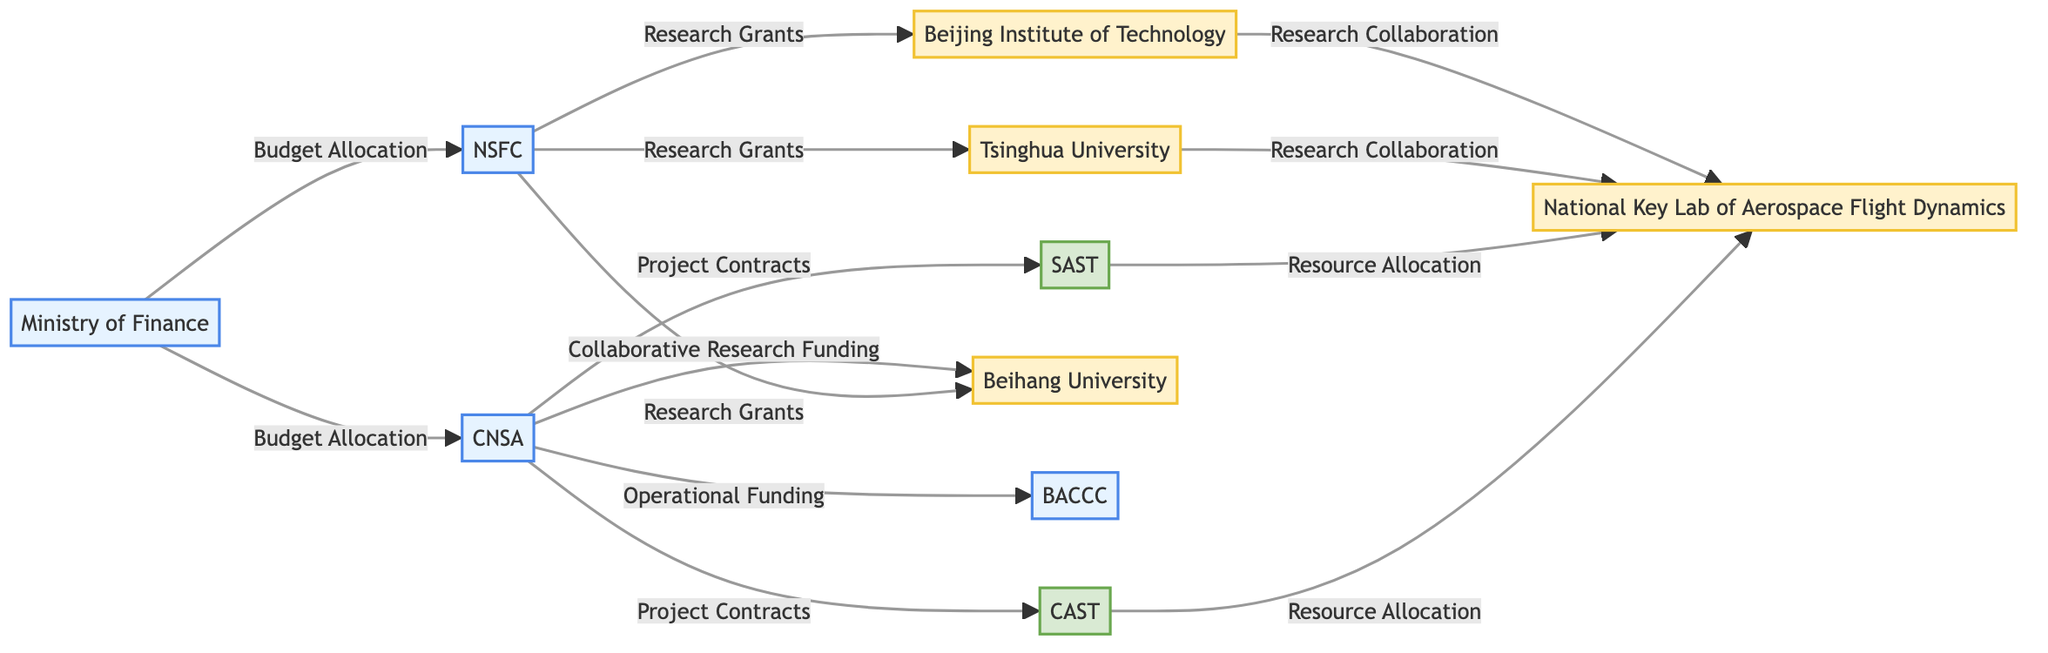What is the total number of nodes in the diagram? The diagram includes nodes representing various entities involved in space debris management. By counting the individual nodes listed, we find that there are 10 distinct nodes.
Answer: 10 Which government agency has connections to Beijing Aerospace Command and Control Center? According to the edges in the diagram, the China National Space Administration has a direct connection to the Beijing Aerospace Command and Control Center through Operational Funding.
Answer: CNSA How many research institutions received research grants from NSFC? The diagram indicates three research institutions that have incoming edges from the National Natural Science Foundation for research grants: Tsinghua University, Beijing Institute of Technology, and Beihang University. Counting these gives us a total of three institutions.
Answer: 3 What type of funding connects CNSA to CAST? The diagram specifies that the connection between CNSA and CAST is through Project Contracts. This funding type is shown explicitly in the edges of the diagram linking these two nodes.
Answer: Project Contracts Which node has the most outgoing connections? Evaluating the outgoing edges from each node, we see that the China National Space Administration has four outgoing connections: to BACCC, CAST, SAST, and Beihang University. No other node exceeds this count, indicating that CNSA has the most connections.
Answer: CNSA Which research institution collaborates with both NSFC and CAST? The edge from NSFC to Tsinghua University and the edge from CAST to National Key Laboratory of Aerospace Flight Dynamics collectively suggest that Tsinghua University has collaborations with NSFC and another link to CAST through resource allocation. Thus, Tsinghua University is the institution that links to both.
Answer: Tsinghua University What is the main source of budget allocation for CNSA? According to the diagram, the main source of budget allocation for the China National Space Administration is indicated to come from the Ministry of Finance, as shown by the connecting edge between the two nodes.
Answer: Ministry of Finance Identify the relationship type between Beijing Institute of Technology and the National Key Laboratory of Aerospace Flight Dynamics. In the diagram, the (Beijing Institute of Technology connects to National Key Laboratory of Aerospace Flight Dynamics through a Research Collaboration edge, indicating a cooperative relationship.
Answer: Research Collaboration How many private firms are involved in project contracts with CNSA? The diagram illustrates that there are two private firms linked through Project Contracts to CNSA, which are China Academy of Space Technology and Shanghai Academy of Spaceflight Technology. Therefore, the count of private firms in this context is two.
Answer: 2 